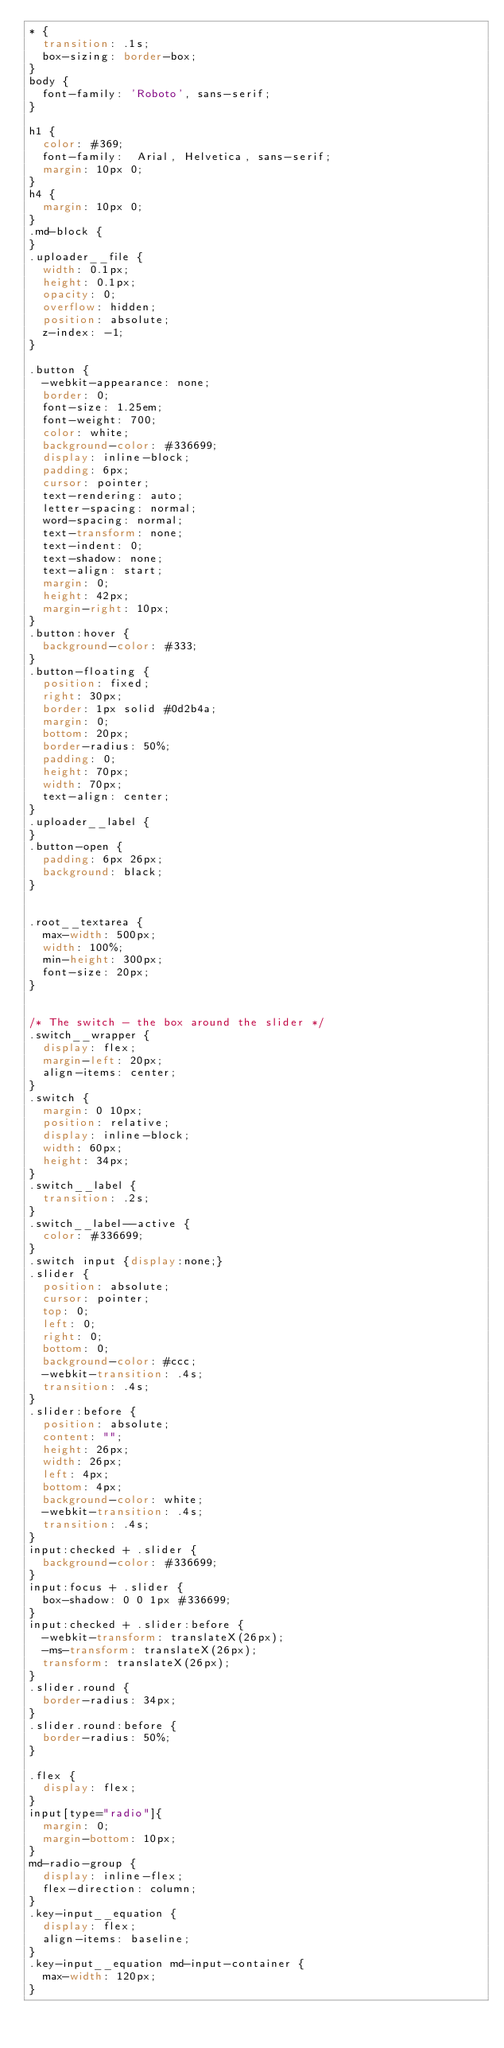<code> <loc_0><loc_0><loc_500><loc_500><_CSS_>* {
  transition: .1s;
  box-sizing: border-box;
}
body {
  font-family: 'Roboto', sans-serif;
}

h1 {
  color: #369;
  font-family:  Arial, Helvetica, sans-serif;
  margin: 10px 0;
}
h4 {
  margin: 10px 0;
}
.md-block {
}
.uploader__file {
  width: 0.1px;
  height: 0.1px;
  opacity: 0;
  overflow: hidden;
  position: absolute;
  z-index: -1;
}

.button {
  -webkit-appearance: none;
  border: 0;
  font-size: 1.25em;
  font-weight: 700;
  color: white;
  background-color: #336699;
  display: inline-block;
  padding: 6px;
  cursor: pointer;
  text-rendering: auto;
  letter-spacing: normal;
  word-spacing: normal;
  text-transform: none;
  text-indent: 0;
  text-shadow: none;
  text-align: start;
  margin: 0;
  height: 42px;
  margin-right: 10px;
}
.button:hover {
  background-color: #333;
}
.button-floating {
  position: fixed;
  right: 30px;
  border: 1px solid #0d2b4a;
  margin: 0;
  bottom: 20px;
  border-radius: 50%;
  padding: 0;
  height: 70px;
  width: 70px;
  text-align: center;
}
.uploader__label {
}
.button-open {
  padding: 6px 26px;
  background: black;
}


.root__textarea {
  max-width: 500px;
  width: 100%;
  min-height: 300px;
  font-size: 20px;
}


/* The switch - the box around the slider */
.switch__wrapper {
  display: flex;
  margin-left: 20px;
  align-items: center;
}
.switch {
  margin: 0 10px;
  position: relative;
  display: inline-block;
  width: 60px;
  height: 34px;
}
.switch__label {
  transition: .2s;
}
.switch__label--active {
  color: #336699;
}
.switch input {display:none;}
.slider {
  position: absolute;
  cursor: pointer;
  top: 0;
  left: 0;
  right: 0;
  bottom: 0;
  background-color: #ccc;
  -webkit-transition: .4s;
  transition: .4s;
}
.slider:before {
  position: absolute;
  content: "";
  height: 26px;
  width: 26px;
  left: 4px;
  bottom: 4px;
  background-color: white;
  -webkit-transition: .4s;
  transition: .4s;
}
input:checked + .slider {
  background-color: #336699;
}
input:focus + .slider {
  box-shadow: 0 0 1px #336699;
}
input:checked + .slider:before {
  -webkit-transform: translateX(26px);
  -ms-transform: translateX(26px);
  transform: translateX(26px);
}
.slider.round {
  border-radius: 34px;
}
.slider.round:before {
  border-radius: 50%;
}

.flex {
  display: flex;
}
input[type="radio"]{
  margin: 0;
  margin-bottom: 10px;
}
md-radio-group {
  display: inline-flex;
  flex-direction: column;
}
.key-input__equation {
  display: flex;
  align-items: baseline;
}
.key-input__equation md-input-container {
  max-width: 120px;
}
</code> 